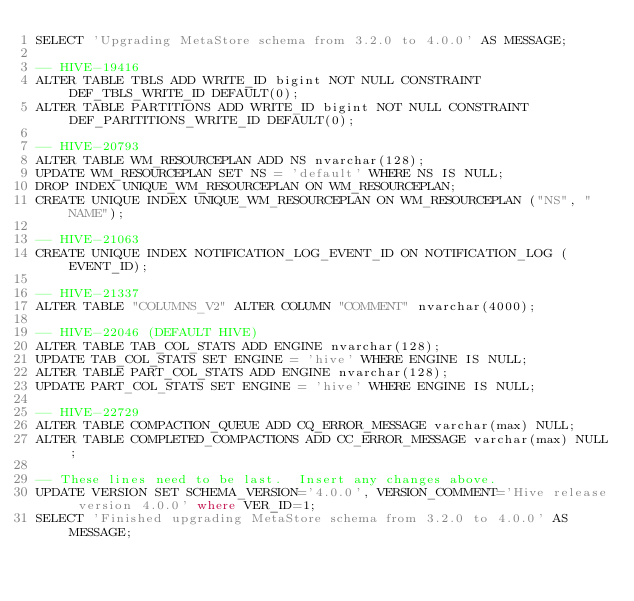Convert code to text. <code><loc_0><loc_0><loc_500><loc_500><_SQL_>SELECT 'Upgrading MetaStore schema from 3.2.0 to 4.0.0' AS MESSAGE;

-- HIVE-19416
ALTER TABLE TBLS ADD WRITE_ID bigint NOT NULL CONSTRAINT DEF_TBLS_WRITE_ID DEFAULT(0);
ALTER TABLE PARTITIONS ADD WRITE_ID bigint NOT NULL CONSTRAINT DEF_PARITITIONS_WRITE_ID DEFAULT(0);

-- HIVE-20793
ALTER TABLE WM_RESOURCEPLAN ADD NS nvarchar(128);
UPDATE WM_RESOURCEPLAN SET NS = 'default' WHERE NS IS NULL;
DROP INDEX UNIQUE_WM_RESOURCEPLAN ON WM_RESOURCEPLAN;
CREATE UNIQUE INDEX UNIQUE_WM_RESOURCEPLAN ON WM_RESOURCEPLAN ("NS", "NAME");

-- HIVE-21063
CREATE UNIQUE INDEX NOTIFICATION_LOG_EVENT_ID ON NOTIFICATION_LOG (EVENT_ID);

-- HIVE-21337
ALTER TABLE "COLUMNS_V2" ALTER COLUMN "COMMENT" nvarchar(4000);

-- HIVE-22046 (DEFAULT HIVE)
ALTER TABLE TAB_COL_STATS ADD ENGINE nvarchar(128);
UPDATE TAB_COL_STATS SET ENGINE = 'hive' WHERE ENGINE IS NULL;
ALTER TABLE PART_COL_STATS ADD ENGINE nvarchar(128);
UPDATE PART_COL_STATS SET ENGINE = 'hive' WHERE ENGINE IS NULL;

-- HIVE-22729
ALTER TABLE COMPACTION_QUEUE ADD CQ_ERROR_MESSAGE varchar(max) NULL;
ALTER TABLE COMPLETED_COMPACTIONS ADD CC_ERROR_MESSAGE varchar(max) NULL;

-- These lines need to be last.  Insert any changes above.
UPDATE VERSION SET SCHEMA_VERSION='4.0.0', VERSION_COMMENT='Hive release version 4.0.0' where VER_ID=1;
SELECT 'Finished upgrading MetaStore schema from 3.2.0 to 4.0.0' AS MESSAGE;

</code> 